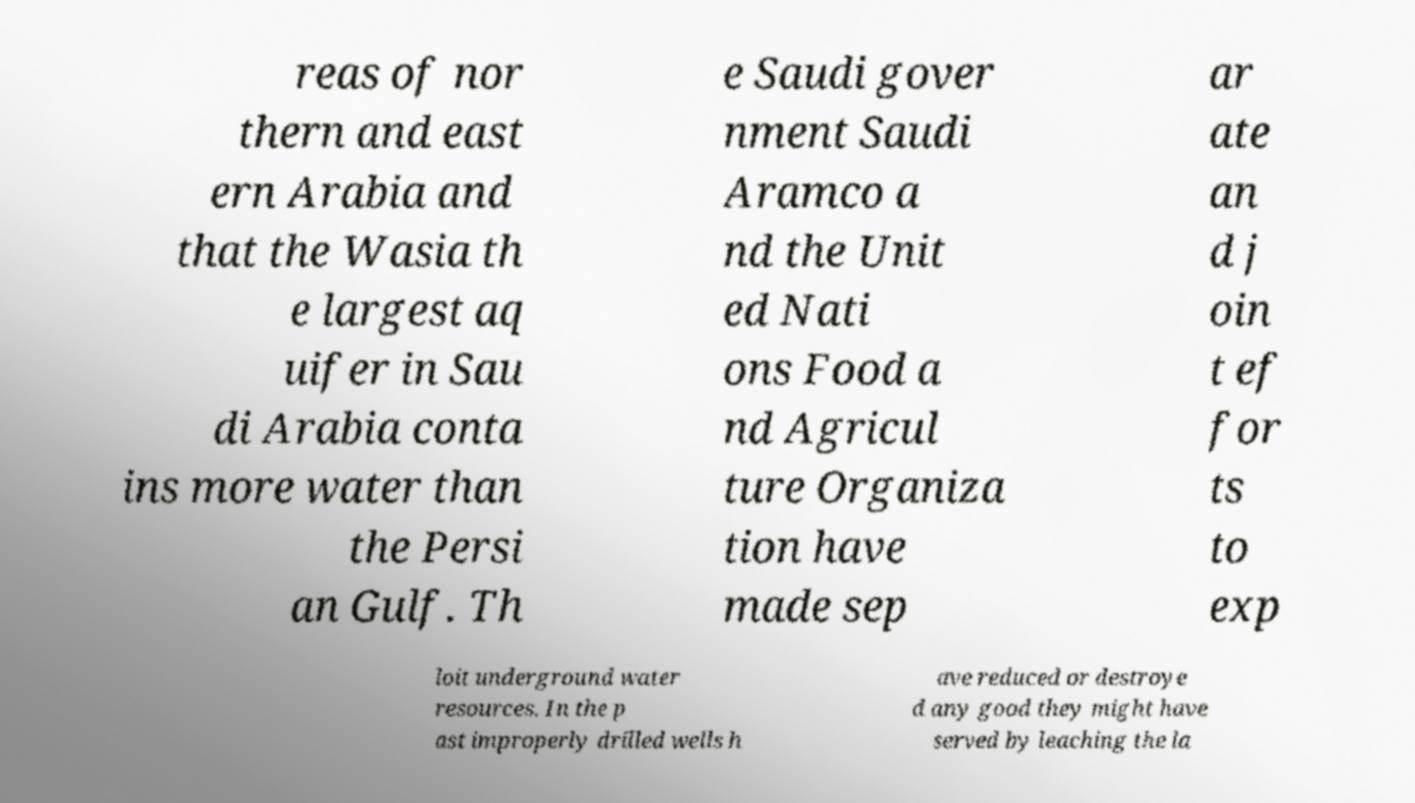For documentation purposes, I need the text within this image transcribed. Could you provide that? reas of nor thern and east ern Arabia and that the Wasia th e largest aq uifer in Sau di Arabia conta ins more water than the Persi an Gulf. Th e Saudi gover nment Saudi Aramco a nd the Unit ed Nati ons Food a nd Agricul ture Organiza tion have made sep ar ate an d j oin t ef for ts to exp loit underground water resources. In the p ast improperly drilled wells h ave reduced or destroye d any good they might have served by leaching the la 